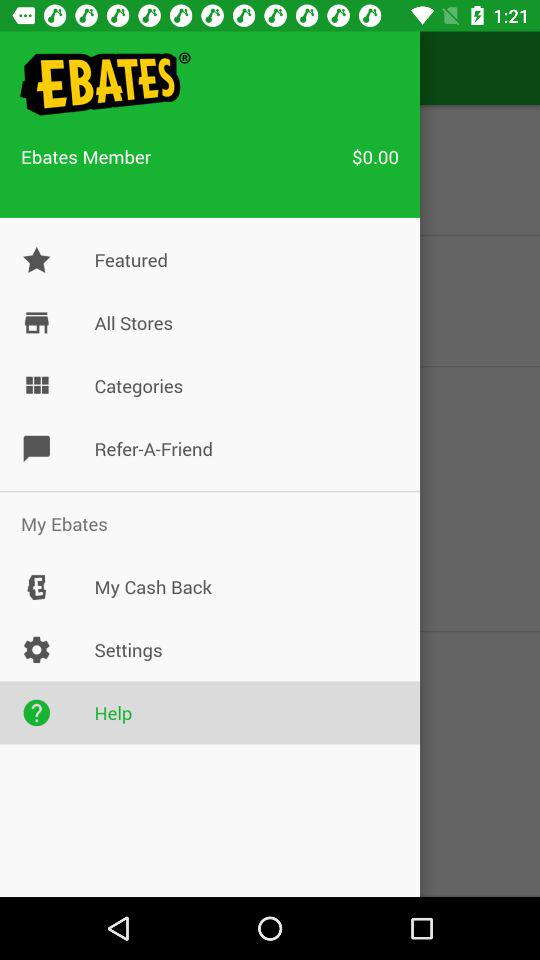How much money is in the account?
Answer the question using a single word or phrase. $0.00 